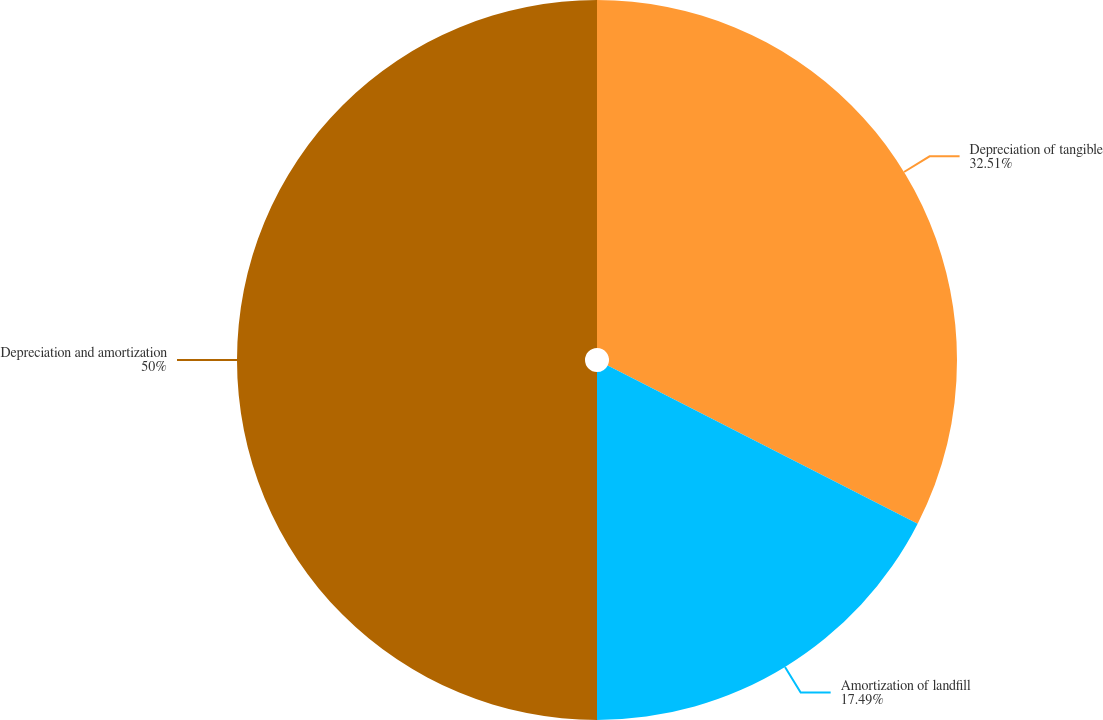Convert chart to OTSL. <chart><loc_0><loc_0><loc_500><loc_500><pie_chart><fcel>Depreciation of tangible<fcel>Amortization of landfill<fcel>Depreciation and amortization<nl><fcel>32.51%<fcel>17.49%<fcel>50.0%<nl></chart> 